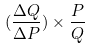Convert formula to latex. <formula><loc_0><loc_0><loc_500><loc_500>( \frac { \Delta Q } { \Delta P } ) \times \frac { P } { Q }</formula> 